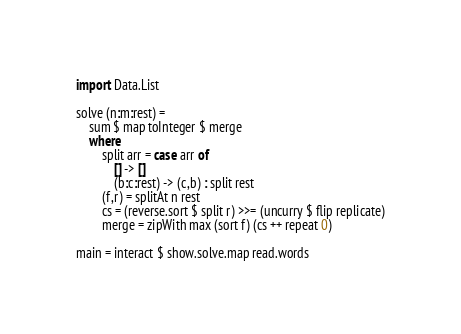Convert code to text. <code><loc_0><loc_0><loc_500><loc_500><_Haskell_>import Data.List

solve (n:m:rest) =
    sum $ map toInteger $ merge
    where
        split arr = case arr of 
            [] -> []
            (b:c:rest) -> (c,b) : split rest
        (f,r) = splitAt n rest
        cs = (reverse.sort $ split r) >>= (uncurry $ flip replicate)
        merge = zipWith max (sort f) (cs ++ repeat 0)

main = interact $ show.solve.map read.words</code> 